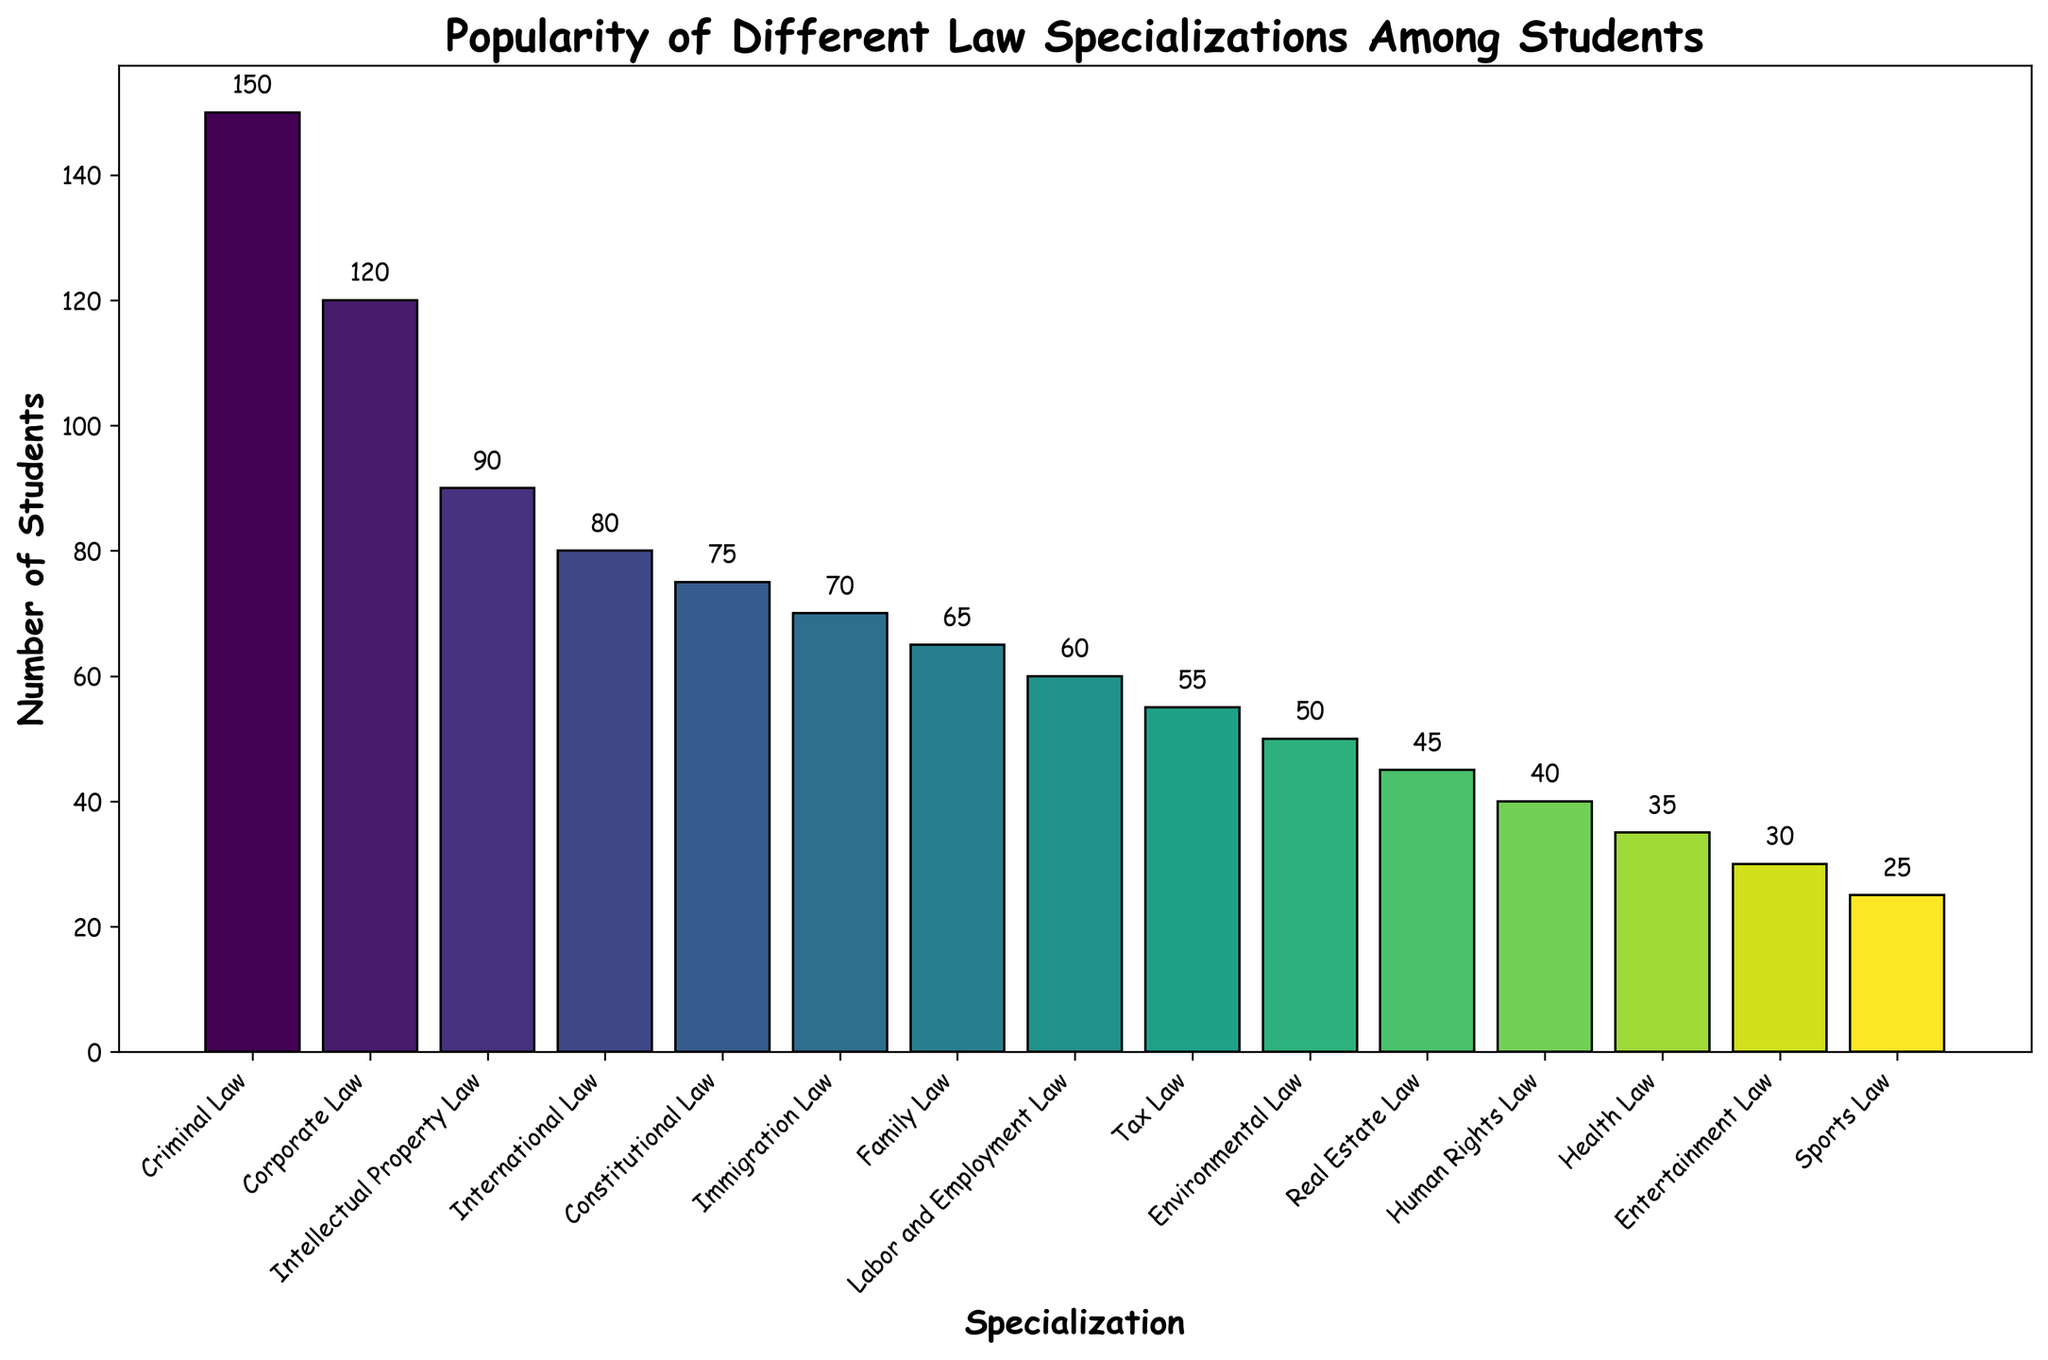What is the most popular law specialization among students? By looking at the chart, the bar for Criminal Law is the tallest, indicating the highest number of students.
Answer: Criminal Law Which law specialization has fewer students: Health Law or Real Estate Law? By comparing the two bars for Health Law and Real Estate Law, it's clear that the Health Law bar is shorter.
Answer: Health Law How many students are interested in Corporate Law and Environmental Law combined? The number of students in Corporate Law is 120, and in Environmental Law, it's 50. Adding them together gives 120 + 50 = 170.
Answer: 170 Which specialization has a greater number of students: Family Law or Immigration Law? Comparing the bars of Family Law and Immigration Law, Immigration Law has a higher number of students at 70 compared to Family Law's 65.
Answer: Immigration Law What is the difference in the number of students between the most and least popular specializations? The most popular specialization, Criminal Law, has 150 students, and the least popular, Sports Law, has 25. The difference is 150 - 25 = 125.
Answer: 125 Among Constitutional Law, International Law, and Labor and Employment Law, which has the smallest student interest? By comparing the bars, Labor and Employment Law has 60 students, which is fewer than Constitutional Law's 75 and International Law's 80.
Answer: Labor and Employment Law What is the average number of students across all specializations? To find the average, sum up the student numbers across all 15 specializations (150 + 120 + 80 + 75 + 50 + 65 + 90 + 60 + 55 + 40 + 30 + 45 + 35 + 25 + 70) = 990. Then, divide by the number of specializations: 990 / 15 = 66.
Answer: 66 How does the height of the bar for Intellectual Property Law compare to that of Tax Law? The bar for Intellectual Property Law (90 students) is taller than the bar for Tax Law (55 students).
Answer: Taller Which specializations have a number of students that falls below the average number of students across all specializations? The average number of students is 66. Specializations below this mark are Environmental Law (50), Labor and Employment Law (60), Tax Law (55), Human Rights Law (40), Entertainment Law (30), Real Estate Law (45), Health Law (35), and Sports Law (25).
Answer: Environmental Law, Labor and Employment Law, Tax Law, Human Rights Law, Entertainment Law, Real Estate Law, Health Law, Sports Law 